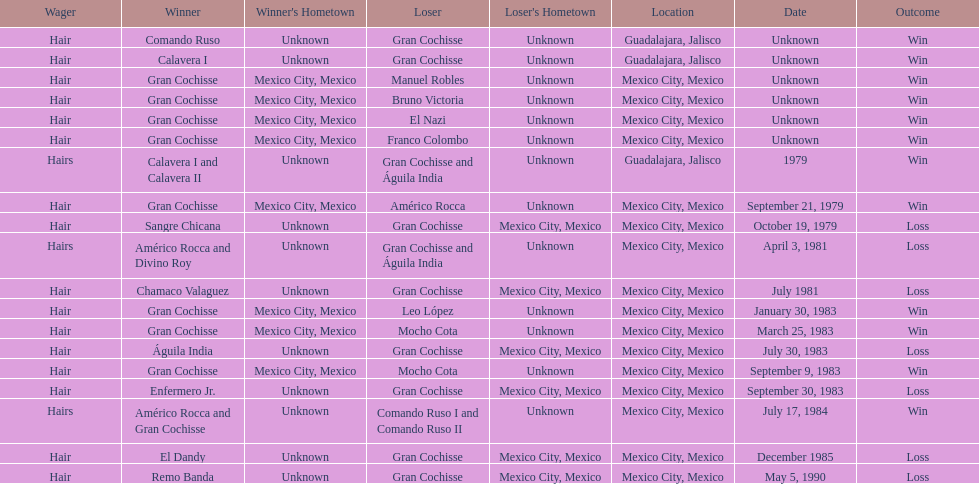How many games more than chamaco valaguez did sangre chicana win? 0. 